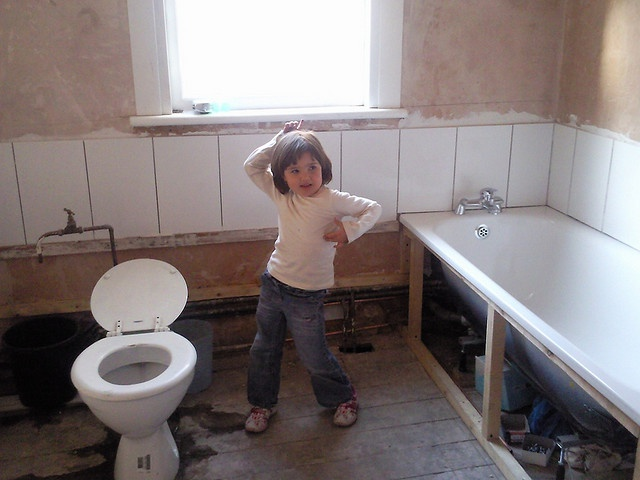Describe the objects in this image and their specific colors. I can see people in gray, black, and darkgray tones and toilet in gray, darkgray, and lightgray tones in this image. 